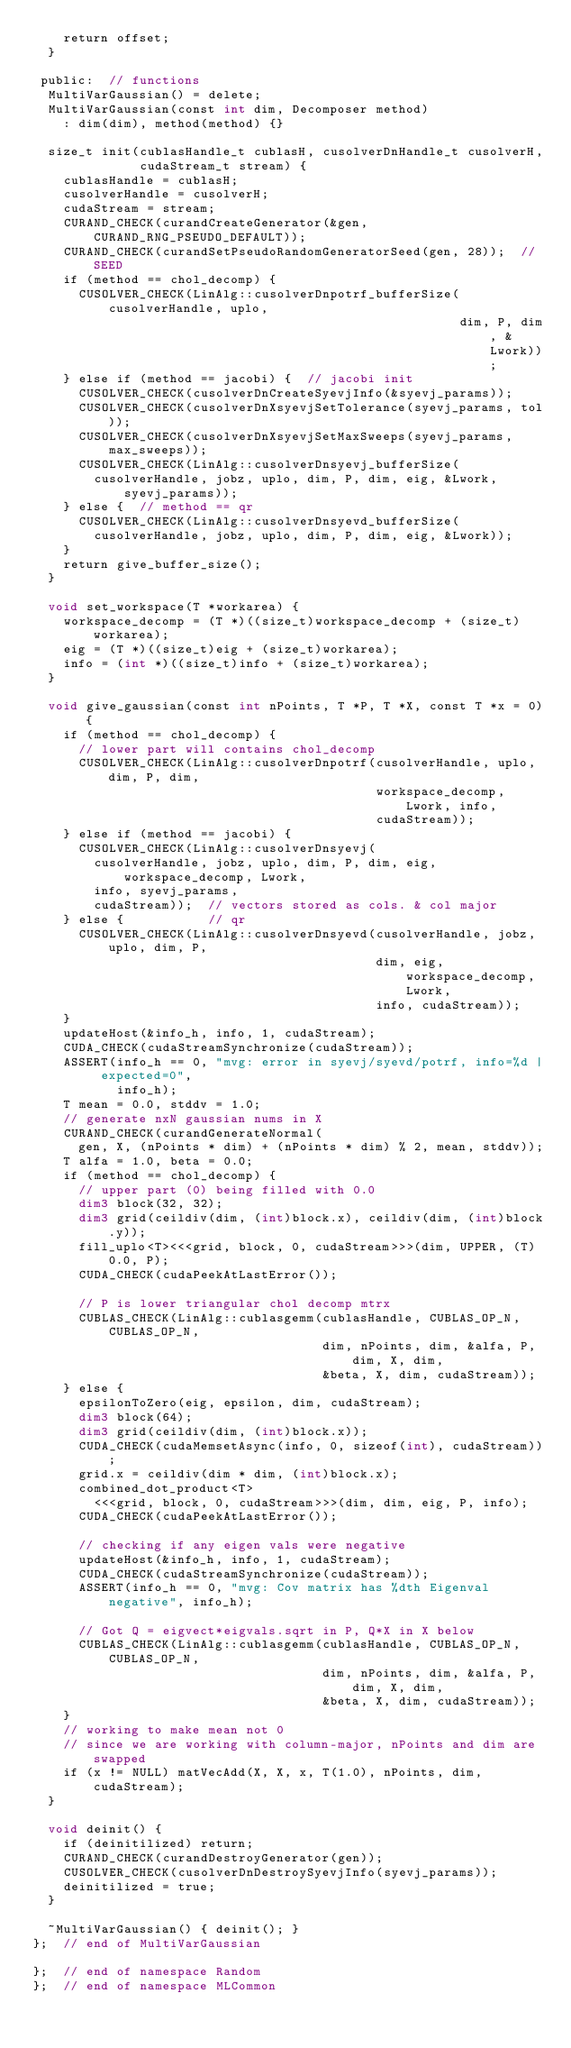Convert code to text. <code><loc_0><loc_0><loc_500><loc_500><_Cuda_>    return offset;
  }

 public:  // functions
  MultiVarGaussian() = delete;
  MultiVarGaussian(const int dim, Decomposer method)
    : dim(dim), method(method) {}

  size_t init(cublasHandle_t cublasH, cusolverDnHandle_t cusolverH,
              cudaStream_t stream) {
    cublasHandle = cublasH;
    cusolverHandle = cusolverH;
    cudaStream = stream;
    CURAND_CHECK(curandCreateGenerator(&gen, CURAND_RNG_PSEUDO_DEFAULT));
    CURAND_CHECK(curandSetPseudoRandomGeneratorSeed(gen, 28));  // SEED
    if (method == chol_decomp) {
      CUSOLVER_CHECK(LinAlg::cusolverDnpotrf_bufferSize(cusolverHandle, uplo,
                                                        dim, P, dim, &Lwork));
    } else if (method == jacobi) {  // jacobi init
      CUSOLVER_CHECK(cusolverDnCreateSyevjInfo(&syevj_params));
      CUSOLVER_CHECK(cusolverDnXsyevjSetTolerance(syevj_params, tol));
      CUSOLVER_CHECK(cusolverDnXsyevjSetMaxSweeps(syevj_params, max_sweeps));
      CUSOLVER_CHECK(LinAlg::cusolverDnsyevj_bufferSize(
        cusolverHandle, jobz, uplo, dim, P, dim, eig, &Lwork, syevj_params));
    } else {  // method == qr
      CUSOLVER_CHECK(LinAlg::cusolverDnsyevd_bufferSize(
        cusolverHandle, jobz, uplo, dim, P, dim, eig, &Lwork));
    }
    return give_buffer_size();
  }

  void set_workspace(T *workarea) {
    workspace_decomp = (T *)((size_t)workspace_decomp + (size_t)workarea);
    eig = (T *)((size_t)eig + (size_t)workarea);
    info = (int *)((size_t)info + (size_t)workarea);
  }

  void give_gaussian(const int nPoints, T *P, T *X, const T *x = 0) {
    if (method == chol_decomp) {
      // lower part will contains chol_decomp
      CUSOLVER_CHECK(LinAlg::cusolverDnpotrf(cusolverHandle, uplo, dim, P, dim,
                                             workspace_decomp, Lwork, info,
                                             cudaStream));
    } else if (method == jacobi) {
      CUSOLVER_CHECK(LinAlg::cusolverDnsyevj(
        cusolverHandle, jobz, uplo, dim, P, dim, eig, workspace_decomp, Lwork,
        info, syevj_params,
        cudaStream));  // vectors stored as cols. & col major
    } else {           // qr
      CUSOLVER_CHECK(LinAlg::cusolverDnsyevd(cusolverHandle, jobz, uplo, dim, P,
                                             dim, eig, workspace_decomp, Lwork,
                                             info, cudaStream));
    }
    updateHost(&info_h, info, 1, cudaStream);
    CUDA_CHECK(cudaStreamSynchronize(cudaStream));
    ASSERT(info_h == 0, "mvg: error in syevj/syevd/potrf, info=%d | expected=0",
           info_h);
    T mean = 0.0, stddv = 1.0;
    // generate nxN gaussian nums in X
    CURAND_CHECK(curandGenerateNormal(
      gen, X, (nPoints * dim) + (nPoints * dim) % 2, mean, stddv));
    T alfa = 1.0, beta = 0.0;
    if (method == chol_decomp) {
      // upper part (0) being filled with 0.0
      dim3 block(32, 32);
      dim3 grid(ceildiv(dim, (int)block.x), ceildiv(dim, (int)block.y));
      fill_uplo<T><<<grid, block, 0, cudaStream>>>(dim, UPPER, (T)0.0, P);
      CUDA_CHECK(cudaPeekAtLastError());

      // P is lower triangular chol decomp mtrx
      CUBLAS_CHECK(LinAlg::cublasgemm(cublasHandle, CUBLAS_OP_N, CUBLAS_OP_N,
                                      dim, nPoints, dim, &alfa, P, dim, X, dim,
                                      &beta, X, dim, cudaStream));
    } else {
      epsilonToZero(eig, epsilon, dim, cudaStream);
      dim3 block(64);
      dim3 grid(ceildiv(dim, (int)block.x));
      CUDA_CHECK(cudaMemsetAsync(info, 0, sizeof(int), cudaStream));
      grid.x = ceildiv(dim * dim, (int)block.x);
      combined_dot_product<T>
        <<<grid, block, 0, cudaStream>>>(dim, dim, eig, P, info);
      CUDA_CHECK(cudaPeekAtLastError());

      // checking if any eigen vals were negative
      updateHost(&info_h, info, 1, cudaStream);
      CUDA_CHECK(cudaStreamSynchronize(cudaStream));
      ASSERT(info_h == 0, "mvg: Cov matrix has %dth Eigenval negative", info_h);

      // Got Q = eigvect*eigvals.sqrt in P, Q*X in X below
      CUBLAS_CHECK(LinAlg::cublasgemm(cublasHandle, CUBLAS_OP_N, CUBLAS_OP_N,
                                      dim, nPoints, dim, &alfa, P, dim, X, dim,
                                      &beta, X, dim, cudaStream));
    }
    // working to make mean not 0
    // since we are working with column-major, nPoints and dim are swapped
    if (x != NULL) matVecAdd(X, X, x, T(1.0), nPoints, dim, cudaStream);
  }

  void deinit() {
    if (deinitilized) return;
    CURAND_CHECK(curandDestroyGenerator(gen));
    CUSOLVER_CHECK(cusolverDnDestroySyevjInfo(syevj_params));
    deinitilized = true;
  }

  ~MultiVarGaussian() { deinit(); }
};  // end of MultiVarGaussian

};  // end of namespace Random
};  // end of namespace MLCommon
</code> 